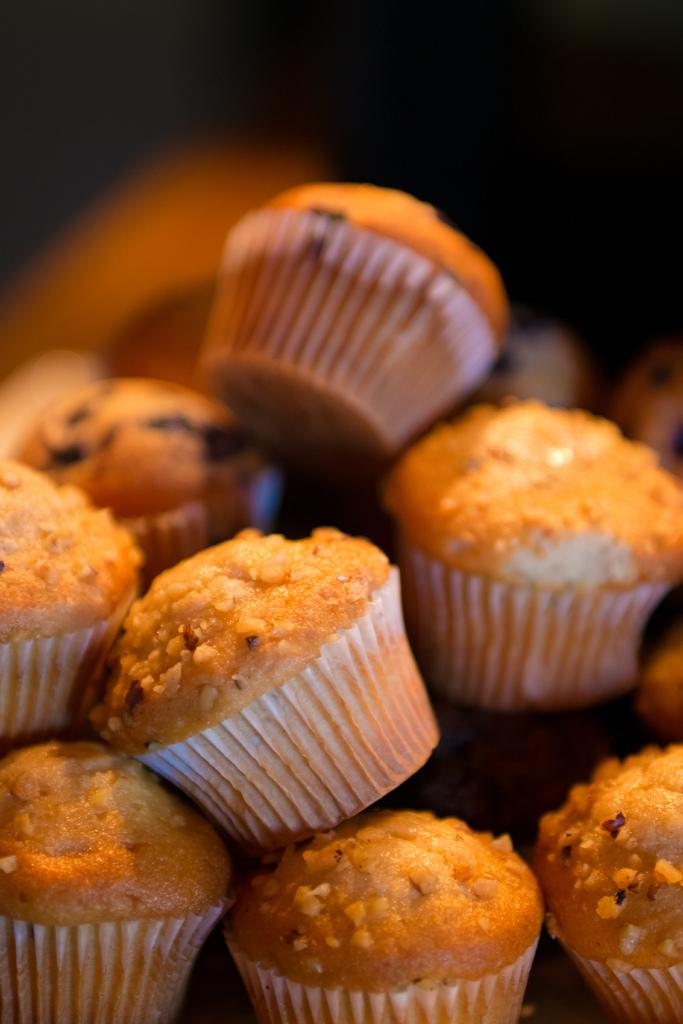What type of food is present in the image? There are cupcakes in the image. Can you describe the background of the image? The background of the image is dark. What type of drum is being played in the background of the image? There is no drum present in the image; it only features cupcakes and a dark background. 